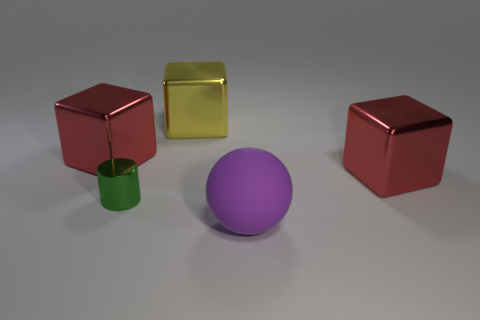There is a green cylinder in front of the red block that is on the right side of the sphere; what is its size?
Provide a short and direct response. Small. The large purple rubber thing has what shape?
Your answer should be very brief. Sphere. What is the material of the red thing that is on the left side of the sphere?
Offer a terse response. Metal. What color is the shiny object that is right of the big purple matte ball in front of the red metallic block on the right side of the yellow metallic object?
Give a very brief answer. Red. The other rubber thing that is the same size as the yellow thing is what color?
Keep it short and to the point. Purple. How many metallic things are large yellow cylinders or large objects?
Your answer should be compact. 3. There is a cylinder that is made of the same material as the big yellow cube; what color is it?
Offer a very short reply. Green. What material is the large red object that is behind the metal block to the right of the purple thing?
Provide a short and direct response. Metal. How many things are large red things that are left of the matte thing or rubber objects on the right side of the green object?
Offer a terse response. 2. There is a red metallic object to the right of the red metal object behind the thing that is to the right of the big rubber thing; what size is it?
Provide a succinct answer. Large. 